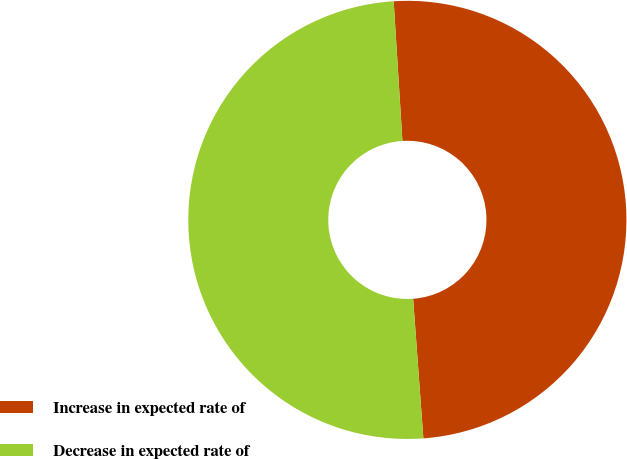Convert chart. <chart><loc_0><loc_0><loc_500><loc_500><pie_chart><fcel>Increase in expected rate of<fcel>Decrease in expected rate of<nl><fcel>49.83%<fcel>50.17%<nl></chart> 